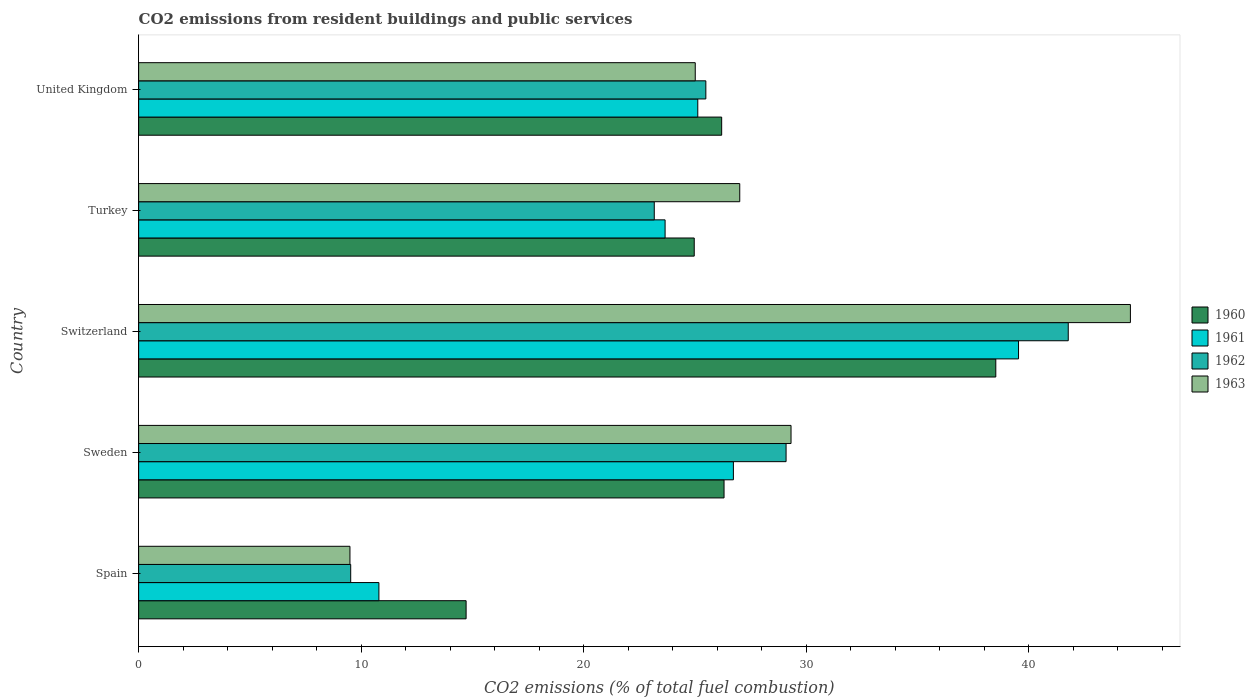How many different coloured bars are there?
Make the answer very short. 4. How many groups of bars are there?
Make the answer very short. 5. Are the number of bars on each tick of the Y-axis equal?
Make the answer very short. Yes. How many bars are there on the 1st tick from the top?
Make the answer very short. 4. What is the label of the 5th group of bars from the top?
Offer a very short reply. Spain. What is the total CO2 emitted in 1960 in Switzerland?
Offer a very short reply. 38.52. Across all countries, what is the maximum total CO2 emitted in 1961?
Your answer should be compact. 39.54. Across all countries, what is the minimum total CO2 emitted in 1960?
Offer a very short reply. 14.72. In which country was the total CO2 emitted in 1960 maximum?
Your response must be concise. Switzerland. What is the total total CO2 emitted in 1963 in the graph?
Offer a very short reply. 135.42. What is the difference between the total CO2 emitted in 1961 in Sweden and that in Turkey?
Ensure brevity in your answer.  3.07. What is the difference between the total CO2 emitted in 1960 in Switzerland and the total CO2 emitted in 1962 in United Kingdom?
Offer a terse response. 13.03. What is the average total CO2 emitted in 1961 per country?
Your answer should be very brief. 25.17. What is the difference between the total CO2 emitted in 1961 and total CO2 emitted in 1960 in Turkey?
Give a very brief answer. -1.31. What is the ratio of the total CO2 emitted in 1961 in Spain to that in United Kingdom?
Give a very brief answer. 0.43. What is the difference between the highest and the second highest total CO2 emitted in 1961?
Keep it short and to the point. 12.81. What is the difference between the highest and the lowest total CO2 emitted in 1963?
Ensure brevity in your answer.  35.07. In how many countries, is the total CO2 emitted in 1960 greater than the average total CO2 emitted in 1960 taken over all countries?
Provide a short and direct response. 3. What does the 3rd bar from the bottom in Sweden represents?
Offer a terse response. 1962. Is it the case that in every country, the sum of the total CO2 emitted in 1963 and total CO2 emitted in 1962 is greater than the total CO2 emitted in 1960?
Your answer should be compact. Yes. How many bars are there?
Ensure brevity in your answer.  20. Does the graph contain any zero values?
Offer a terse response. No. How many legend labels are there?
Offer a very short reply. 4. How are the legend labels stacked?
Your answer should be very brief. Vertical. What is the title of the graph?
Keep it short and to the point. CO2 emissions from resident buildings and public services. Does "1995" appear as one of the legend labels in the graph?
Make the answer very short. No. What is the label or title of the X-axis?
Provide a succinct answer. CO2 emissions (% of total fuel combustion). What is the CO2 emissions (% of total fuel combustion) in 1960 in Spain?
Your answer should be very brief. 14.72. What is the CO2 emissions (% of total fuel combustion) in 1961 in Spain?
Make the answer very short. 10.8. What is the CO2 emissions (% of total fuel combustion) in 1962 in Spain?
Your answer should be compact. 9.53. What is the CO2 emissions (% of total fuel combustion) of 1963 in Spain?
Your answer should be very brief. 9.5. What is the CO2 emissions (% of total fuel combustion) in 1960 in Sweden?
Provide a short and direct response. 26.31. What is the CO2 emissions (% of total fuel combustion) of 1961 in Sweden?
Give a very brief answer. 26.73. What is the CO2 emissions (% of total fuel combustion) of 1962 in Sweden?
Ensure brevity in your answer.  29.1. What is the CO2 emissions (% of total fuel combustion) in 1963 in Sweden?
Your answer should be very brief. 29.32. What is the CO2 emissions (% of total fuel combustion) in 1960 in Switzerland?
Offer a very short reply. 38.52. What is the CO2 emissions (% of total fuel combustion) of 1961 in Switzerland?
Offer a very short reply. 39.54. What is the CO2 emissions (% of total fuel combustion) in 1962 in Switzerland?
Provide a succinct answer. 41.78. What is the CO2 emissions (% of total fuel combustion) of 1963 in Switzerland?
Keep it short and to the point. 44.57. What is the CO2 emissions (% of total fuel combustion) of 1960 in Turkey?
Your answer should be compact. 24.97. What is the CO2 emissions (% of total fuel combustion) in 1961 in Turkey?
Ensure brevity in your answer.  23.66. What is the CO2 emissions (% of total fuel combustion) of 1962 in Turkey?
Offer a very short reply. 23.17. What is the CO2 emissions (% of total fuel combustion) in 1963 in Turkey?
Offer a terse response. 27.01. What is the CO2 emissions (% of total fuel combustion) of 1960 in United Kingdom?
Provide a short and direct response. 26.2. What is the CO2 emissions (% of total fuel combustion) of 1961 in United Kingdom?
Provide a succinct answer. 25.13. What is the CO2 emissions (% of total fuel combustion) in 1962 in United Kingdom?
Your answer should be very brief. 25.49. What is the CO2 emissions (% of total fuel combustion) of 1963 in United Kingdom?
Provide a short and direct response. 25.01. Across all countries, what is the maximum CO2 emissions (% of total fuel combustion) in 1960?
Your answer should be very brief. 38.52. Across all countries, what is the maximum CO2 emissions (% of total fuel combustion) in 1961?
Keep it short and to the point. 39.54. Across all countries, what is the maximum CO2 emissions (% of total fuel combustion) in 1962?
Give a very brief answer. 41.78. Across all countries, what is the maximum CO2 emissions (% of total fuel combustion) of 1963?
Ensure brevity in your answer.  44.57. Across all countries, what is the minimum CO2 emissions (% of total fuel combustion) of 1960?
Give a very brief answer. 14.72. Across all countries, what is the minimum CO2 emissions (% of total fuel combustion) of 1961?
Offer a terse response. 10.8. Across all countries, what is the minimum CO2 emissions (% of total fuel combustion) of 1962?
Offer a terse response. 9.53. Across all countries, what is the minimum CO2 emissions (% of total fuel combustion) in 1963?
Ensure brevity in your answer.  9.5. What is the total CO2 emissions (% of total fuel combustion) of 1960 in the graph?
Provide a short and direct response. 130.72. What is the total CO2 emissions (% of total fuel combustion) of 1961 in the graph?
Give a very brief answer. 125.86. What is the total CO2 emissions (% of total fuel combustion) in 1962 in the graph?
Your answer should be very brief. 129.07. What is the total CO2 emissions (% of total fuel combustion) in 1963 in the graph?
Offer a terse response. 135.42. What is the difference between the CO2 emissions (% of total fuel combustion) in 1960 in Spain and that in Sweden?
Give a very brief answer. -11.59. What is the difference between the CO2 emissions (% of total fuel combustion) in 1961 in Spain and that in Sweden?
Offer a terse response. -15.93. What is the difference between the CO2 emissions (% of total fuel combustion) in 1962 in Spain and that in Sweden?
Offer a very short reply. -19.57. What is the difference between the CO2 emissions (% of total fuel combustion) of 1963 in Spain and that in Sweden?
Your response must be concise. -19.82. What is the difference between the CO2 emissions (% of total fuel combustion) of 1960 in Spain and that in Switzerland?
Your answer should be compact. -23.8. What is the difference between the CO2 emissions (% of total fuel combustion) of 1961 in Spain and that in Switzerland?
Your response must be concise. -28.75. What is the difference between the CO2 emissions (% of total fuel combustion) in 1962 in Spain and that in Switzerland?
Your answer should be compact. -32.25. What is the difference between the CO2 emissions (% of total fuel combustion) of 1963 in Spain and that in Switzerland?
Offer a terse response. -35.07. What is the difference between the CO2 emissions (% of total fuel combustion) in 1960 in Spain and that in Turkey?
Ensure brevity in your answer.  -10.25. What is the difference between the CO2 emissions (% of total fuel combustion) in 1961 in Spain and that in Turkey?
Offer a very short reply. -12.86. What is the difference between the CO2 emissions (% of total fuel combustion) in 1962 in Spain and that in Turkey?
Offer a terse response. -13.64. What is the difference between the CO2 emissions (% of total fuel combustion) in 1963 in Spain and that in Turkey?
Your answer should be compact. -17.52. What is the difference between the CO2 emissions (% of total fuel combustion) in 1960 in Spain and that in United Kingdom?
Keep it short and to the point. -11.49. What is the difference between the CO2 emissions (% of total fuel combustion) of 1961 in Spain and that in United Kingdom?
Your answer should be very brief. -14.33. What is the difference between the CO2 emissions (% of total fuel combustion) of 1962 in Spain and that in United Kingdom?
Offer a very short reply. -15.96. What is the difference between the CO2 emissions (% of total fuel combustion) in 1963 in Spain and that in United Kingdom?
Your answer should be compact. -15.52. What is the difference between the CO2 emissions (% of total fuel combustion) of 1960 in Sweden and that in Switzerland?
Keep it short and to the point. -12.21. What is the difference between the CO2 emissions (% of total fuel combustion) in 1961 in Sweden and that in Switzerland?
Your answer should be compact. -12.81. What is the difference between the CO2 emissions (% of total fuel combustion) in 1962 in Sweden and that in Switzerland?
Make the answer very short. -12.68. What is the difference between the CO2 emissions (% of total fuel combustion) in 1963 in Sweden and that in Switzerland?
Offer a terse response. -15.25. What is the difference between the CO2 emissions (% of total fuel combustion) in 1960 in Sweden and that in Turkey?
Provide a short and direct response. 1.34. What is the difference between the CO2 emissions (% of total fuel combustion) in 1961 in Sweden and that in Turkey?
Your answer should be very brief. 3.07. What is the difference between the CO2 emissions (% of total fuel combustion) of 1962 in Sweden and that in Turkey?
Provide a short and direct response. 5.92. What is the difference between the CO2 emissions (% of total fuel combustion) in 1963 in Sweden and that in Turkey?
Make the answer very short. 2.3. What is the difference between the CO2 emissions (% of total fuel combustion) of 1960 in Sweden and that in United Kingdom?
Keep it short and to the point. 0.11. What is the difference between the CO2 emissions (% of total fuel combustion) in 1961 in Sweden and that in United Kingdom?
Offer a terse response. 1.6. What is the difference between the CO2 emissions (% of total fuel combustion) of 1962 in Sweden and that in United Kingdom?
Keep it short and to the point. 3.61. What is the difference between the CO2 emissions (% of total fuel combustion) in 1963 in Sweden and that in United Kingdom?
Give a very brief answer. 4.3. What is the difference between the CO2 emissions (% of total fuel combustion) in 1960 in Switzerland and that in Turkey?
Ensure brevity in your answer.  13.55. What is the difference between the CO2 emissions (% of total fuel combustion) of 1961 in Switzerland and that in Turkey?
Give a very brief answer. 15.88. What is the difference between the CO2 emissions (% of total fuel combustion) in 1962 in Switzerland and that in Turkey?
Provide a succinct answer. 18.6. What is the difference between the CO2 emissions (% of total fuel combustion) in 1963 in Switzerland and that in Turkey?
Keep it short and to the point. 17.56. What is the difference between the CO2 emissions (% of total fuel combustion) in 1960 in Switzerland and that in United Kingdom?
Offer a very short reply. 12.32. What is the difference between the CO2 emissions (% of total fuel combustion) in 1961 in Switzerland and that in United Kingdom?
Give a very brief answer. 14.42. What is the difference between the CO2 emissions (% of total fuel combustion) of 1962 in Switzerland and that in United Kingdom?
Your answer should be very brief. 16.29. What is the difference between the CO2 emissions (% of total fuel combustion) of 1963 in Switzerland and that in United Kingdom?
Offer a very short reply. 19.56. What is the difference between the CO2 emissions (% of total fuel combustion) of 1960 in Turkey and that in United Kingdom?
Provide a short and direct response. -1.23. What is the difference between the CO2 emissions (% of total fuel combustion) of 1961 in Turkey and that in United Kingdom?
Make the answer very short. -1.47. What is the difference between the CO2 emissions (% of total fuel combustion) of 1962 in Turkey and that in United Kingdom?
Your answer should be compact. -2.32. What is the difference between the CO2 emissions (% of total fuel combustion) of 1963 in Turkey and that in United Kingdom?
Your answer should be very brief. 2. What is the difference between the CO2 emissions (% of total fuel combustion) of 1960 in Spain and the CO2 emissions (% of total fuel combustion) of 1961 in Sweden?
Your answer should be compact. -12.01. What is the difference between the CO2 emissions (% of total fuel combustion) in 1960 in Spain and the CO2 emissions (% of total fuel combustion) in 1962 in Sweden?
Provide a short and direct response. -14.38. What is the difference between the CO2 emissions (% of total fuel combustion) of 1960 in Spain and the CO2 emissions (% of total fuel combustion) of 1963 in Sweden?
Give a very brief answer. -14.6. What is the difference between the CO2 emissions (% of total fuel combustion) of 1961 in Spain and the CO2 emissions (% of total fuel combustion) of 1962 in Sweden?
Your answer should be very brief. -18.3. What is the difference between the CO2 emissions (% of total fuel combustion) of 1961 in Spain and the CO2 emissions (% of total fuel combustion) of 1963 in Sweden?
Your answer should be very brief. -18.52. What is the difference between the CO2 emissions (% of total fuel combustion) of 1962 in Spain and the CO2 emissions (% of total fuel combustion) of 1963 in Sweden?
Keep it short and to the point. -19.79. What is the difference between the CO2 emissions (% of total fuel combustion) in 1960 in Spain and the CO2 emissions (% of total fuel combustion) in 1961 in Switzerland?
Offer a very short reply. -24.83. What is the difference between the CO2 emissions (% of total fuel combustion) of 1960 in Spain and the CO2 emissions (% of total fuel combustion) of 1962 in Switzerland?
Make the answer very short. -27.06. What is the difference between the CO2 emissions (% of total fuel combustion) of 1960 in Spain and the CO2 emissions (% of total fuel combustion) of 1963 in Switzerland?
Keep it short and to the point. -29.85. What is the difference between the CO2 emissions (% of total fuel combustion) in 1961 in Spain and the CO2 emissions (% of total fuel combustion) in 1962 in Switzerland?
Your answer should be very brief. -30.98. What is the difference between the CO2 emissions (% of total fuel combustion) of 1961 in Spain and the CO2 emissions (% of total fuel combustion) of 1963 in Switzerland?
Your response must be concise. -33.77. What is the difference between the CO2 emissions (% of total fuel combustion) in 1962 in Spain and the CO2 emissions (% of total fuel combustion) in 1963 in Switzerland?
Give a very brief answer. -35.04. What is the difference between the CO2 emissions (% of total fuel combustion) of 1960 in Spain and the CO2 emissions (% of total fuel combustion) of 1961 in Turkey?
Ensure brevity in your answer.  -8.94. What is the difference between the CO2 emissions (% of total fuel combustion) in 1960 in Spain and the CO2 emissions (% of total fuel combustion) in 1962 in Turkey?
Your response must be concise. -8.46. What is the difference between the CO2 emissions (% of total fuel combustion) of 1960 in Spain and the CO2 emissions (% of total fuel combustion) of 1963 in Turkey?
Keep it short and to the point. -12.3. What is the difference between the CO2 emissions (% of total fuel combustion) in 1961 in Spain and the CO2 emissions (% of total fuel combustion) in 1962 in Turkey?
Offer a very short reply. -12.38. What is the difference between the CO2 emissions (% of total fuel combustion) of 1961 in Spain and the CO2 emissions (% of total fuel combustion) of 1963 in Turkey?
Give a very brief answer. -16.22. What is the difference between the CO2 emissions (% of total fuel combustion) in 1962 in Spain and the CO2 emissions (% of total fuel combustion) in 1963 in Turkey?
Offer a terse response. -17.48. What is the difference between the CO2 emissions (% of total fuel combustion) of 1960 in Spain and the CO2 emissions (% of total fuel combustion) of 1961 in United Kingdom?
Your answer should be very brief. -10.41. What is the difference between the CO2 emissions (% of total fuel combustion) of 1960 in Spain and the CO2 emissions (% of total fuel combustion) of 1962 in United Kingdom?
Provide a short and direct response. -10.77. What is the difference between the CO2 emissions (% of total fuel combustion) in 1960 in Spain and the CO2 emissions (% of total fuel combustion) in 1963 in United Kingdom?
Offer a terse response. -10.3. What is the difference between the CO2 emissions (% of total fuel combustion) of 1961 in Spain and the CO2 emissions (% of total fuel combustion) of 1962 in United Kingdom?
Offer a terse response. -14.69. What is the difference between the CO2 emissions (% of total fuel combustion) of 1961 in Spain and the CO2 emissions (% of total fuel combustion) of 1963 in United Kingdom?
Give a very brief answer. -14.22. What is the difference between the CO2 emissions (% of total fuel combustion) of 1962 in Spain and the CO2 emissions (% of total fuel combustion) of 1963 in United Kingdom?
Provide a succinct answer. -15.48. What is the difference between the CO2 emissions (% of total fuel combustion) in 1960 in Sweden and the CO2 emissions (% of total fuel combustion) in 1961 in Switzerland?
Ensure brevity in your answer.  -13.23. What is the difference between the CO2 emissions (% of total fuel combustion) of 1960 in Sweden and the CO2 emissions (% of total fuel combustion) of 1962 in Switzerland?
Make the answer very short. -15.47. What is the difference between the CO2 emissions (% of total fuel combustion) of 1960 in Sweden and the CO2 emissions (% of total fuel combustion) of 1963 in Switzerland?
Give a very brief answer. -18.26. What is the difference between the CO2 emissions (% of total fuel combustion) of 1961 in Sweden and the CO2 emissions (% of total fuel combustion) of 1962 in Switzerland?
Your answer should be very brief. -15.05. What is the difference between the CO2 emissions (% of total fuel combustion) of 1961 in Sweden and the CO2 emissions (% of total fuel combustion) of 1963 in Switzerland?
Offer a terse response. -17.84. What is the difference between the CO2 emissions (% of total fuel combustion) in 1962 in Sweden and the CO2 emissions (% of total fuel combustion) in 1963 in Switzerland?
Provide a succinct answer. -15.47. What is the difference between the CO2 emissions (% of total fuel combustion) of 1960 in Sweden and the CO2 emissions (% of total fuel combustion) of 1961 in Turkey?
Your answer should be compact. 2.65. What is the difference between the CO2 emissions (% of total fuel combustion) in 1960 in Sweden and the CO2 emissions (% of total fuel combustion) in 1962 in Turkey?
Give a very brief answer. 3.14. What is the difference between the CO2 emissions (% of total fuel combustion) of 1960 in Sweden and the CO2 emissions (% of total fuel combustion) of 1963 in Turkey?
Your answer should be very brief. -0.71. What is the difference between the CO2 emissions (% of total fuel combustion) of 1961 in Sweden and the CO2 emissions (% of total fuel combustion) of 1962 in Turkey?
Ensure brevity in your answer.  3.56. What is the difference between the CO2 emissions (% of total fuel combustion) in 1961 in Sweden and the CO2 emissions (% of total fuel combustion) in 1963 in Turkey?
Keep it short and to the point. -0.29. What is the difference between the CO2 emissions (% of total fuel combustion) in 1962 in Sweden and the CO2 emissions (% of total fuel combustion) in 1963 in Turkey?
Keep it short and to the point. 2.08. What is the difference between the CO2 emissions (% of total fuel combustion) of 1960 in Sweden and the CO2 emissions (% of total fuel combustion) of 1961 in United Kingdom?
Offer a terse response. 1.18. What is the difference between the CO2 emissions (% of total fuel combustion) of 1960 in Sweden and the CO2 emissions (% of total fuel combustion) of 1962 in United Kingdom?
Provide a succinct answer. 0.82. What is the difference between the CO2 emissions (% of total fuel combustion) of 1960 in Sweden and the CO2 emissions (% of total fuel combustion) of 1963 in United Kingdom?
Ensure brevity in your answer.  1.29. What is the difference between the CO2 emissions (% of total fuel combustion) of 1961 in Sweden and the CO2 emissions (% of total fuel combustion) of 1962 in United Kingdom?
Your response must be concise. 1.24. What is the difference between the CO2 emissions (% of total fuel combustion) in 1961 in Sweden and the CO2 emissions (% of total fuel combustion) in 1963 in United Kingdom?
Provide a short and direct response. 1.71. What is the difference between the CO2 emissions (% of total fuel combustion) of 1962 in Sweden and the CO2 emissions (% of total fuel combustion) of 1963 in United Kingdom?
Offer a very short reply. 4.08. What is the difference between the CO2 emissions (% of total fuel combustion) in 1960 in Switzerland and the CO2 emissions (% of total fuel combustion) in 1961 in Turkey?
Provide a succinct answer. 14.86. What is the difference between the CO2 emissions (% of total fuel combustion) in 1960 in Switzerland and the CO2 emissions (% of total fuel combustion) in 1962 in Turkey?
Provide a succinct answer. 15.35. What is the difference between the CO2 emissions (% of total fuel combustion) of 1960 in Switzerland and the CO2 emissions (% of total fuel combustion) of 1963 in Turkey?
Make the answer very short. 11.51. What is the difference between the CO2 emissions (% of total fuel combustion) of 1961 in Switzerland and the CO2 emissions (% of total fuel combustion) of 1962 in Turkey?
Give a very brief answer. 16.37. What is the difference between the CO2 emissions (% of total fuel combustion) in 1961 in Switzerland and the CO2 emissions (% of total fuel combustion) in 1963 in Turkey?
Give a very brief answer. 12.53. What is the difference between the CO2 emissions (% of total fuel combustion) of 1962 in Switzerland and the CO2 emissions (% of total fuel combustion) of 1963 in Turkey?
Keep it short and to the point. 14.76. What is the difference between the CO2 emissions (% of total fuel combustion) in 1960 in Switzerland and the CO2 emissions (% of total fuel combustion) in 1961 in United Kingdom?
Your response must be concise. 13.39. What is the difference between the CO2 emissions (% of total fuel combustion) of 1960 in Switzerland and the CO2 emissions (% of total fuel combustion) of 1962 in United Kingdom?
Your answer should be very brief. 13.03. What is the difference between the CO2 emissions (% of total fuel combustion) of 1960 in Switzerland and the CO2 emissions (% of total fuel combustion) of 1963 in United Kingdom?
Provide a short and direct response. 13.51. What is the difference between the CO2 emissions (% of total fuel combustion) in 1961 in Switzerland and the CO2 emissions (% of total fuel combustion) in 1962 in United Kingdom?
Your answer should be very brief. 14.05. What is the difference between the CO2 emissions (% of total fuel combustion) in 1961 in Switzerland and the CO2 emissions (% of total fuel combustion) in 1963 in United Kingdom?
Your response must be concise. 14.53. What is the difference between the CO2 emissions (% of total fuel combustion) in 1962 in Switzerland and the CO2 emissions (% of total fuel combustion) in 1963 in United Kingdom?
Your answer should be very brief. 16.76. What is the difference between the CO2 emissions (% of total fuel combustion) of 1960 in Turkey and the CO2 emissions (% of total fuel combustion) of 1961 in United Kingdom?
Offer a very short reply. -0.16. What is the difference between the CO2 emissions (% of total fuel combustion) of 1960 in Turkey and the CO2 emissions (% of total fuel combustion) of 1962 in United Kingdom?
Make the answer very short. -0.52. What is the difference between the CO2 emissions (% of total fuel combustion) in 1960 in Turkey and the CO2 emissions (% of total fuel combustion) in 1963 in United Kingdom?
Make the answer very short. -0.05. What is the difference between the CO2 emissions (% of total fuel combustion) in 1961 in Turkey and the CO2 emissions (% of total fuel combustion) in 1962 in United Kingdom?
Offer a very short reply. -1.83. What is the difference between the CO2 emissions (% of total fuel combustion) in 1961 in Turkey and the CO2 emissions (% of total fuel combustion) in 1963 in United Kingdom?
Provide a succinct answer. -1.35. What is the difference between the CO2 emissions (% of total fuel combustion) in 1962 in Turkey and the CO2 emissions (% of total fuel combustion) in 1963 in United Kingdom?
Give a very brief answer. -1.84. What is the average CO2 emissions (% of total fuel combustion) in 1960 per country?
Make the answer very short. 26.14. What is the average CO2 emissions (% of total fuel combustion) of 1961 per country?
Your response must be concise. 25.17. What is the average CO2 emissions (% of total fuel combustion) in 1962 per country?
Provide a succinct answer. 25.81. What is the average CO2 emissions (% of total fuel combustion) of 1963 per country?
Offer a very short reply. 27.08. What is the difference between the CO2 emissions (% of total fuel combustion) in 1960 and CO2 emissions (% of total fuel combustion) in 1961 in Spain?
Make the answer very short. 3.92. What is the difference between the CO2 emissions (% of total fuel combustion) in 1960 and CO2 emissions (% of total fuel combustion) in 1962 in Spain?
Ensure brevity in your answer.  5.19. What is the difference between the CO2 emissions (% of total fuel combustion) of 1960 and CO2 emissions (% of total fuel combustion) of 1963 in Spain?
Make the answer very short. 5.22. What is the difference between the CO2 emissions (% of total fuel combustion) of 1961 and CO2 emissions (% of total fuel combustion) of 1962 in Spain?
Your answer should be very brief. 1.27. What is the difference between the CO2 emissions (% of total fuel combustion) of 1961 and CO2 emissions (% of total fuel combustion) of 1963 in Spain?
Ensure brevity in your answer.  1.3. What is the difference between the CO2 emissions (% of total fuel combustion) in 1962 and CO2 emissions (% of total fuel combustion) in 1963 in Spain?
Your answer should be compact. 0.03. What is the difference between the CO2 emissions (% of total fuel combustion) in 1960 and CO2 emissions (% of total fuel combustion) in 1961 in Sweden?
Your answer should be very brief. -0.42. What is the difference between the CO2 emissions (% of total fuel combustion) in 1960 and CO2 emissions (% of total fuel combustion) in 1962 in Sweden?
Your response must be concise. -2.79. What is the difference between the CO2 emissions (% of total fuel combustion) of 1960 and CO2 emissions (% of total fuel combustion) of 1963 in Sweden?
Your response must be concise. -3.01. What is the difference between the CO2 emissions (% of total fuel combustion) in 1961 and CO2 emissions (% of total fuel combustion) in 1962 in Sweden?
Provide a succinct answer. -2.37. What is the difference between the CO2 emissions (% of total fuel combustion) of 1961 and CO2 emissions (% of total fuel combustion) of 1963 in Sweden?
Give a very brief answer. -2.59. What is the difference between the CO2 emissions (% of total fuel combustion) of 1962 and CO2 emissions (% of total fuel combustion) of 1963 in Sweden?
Your response must be concise. -0.22. What is the difference between the CO2 emissions (% of total fuel combustion) of 1960 and CO2 emissions (% of total fuel combustion) of 1961 in Switzerland?
Make the answer very short. -1.02. What is the difference between the CO2 emissions (% of total fuel combustion) in 1960 and CO2 emissions (% of total fuel combustion) in 1962 in Switzerland?
Keep it short and to the point. -3.26. What is the difference between the CO2 emissions (% of total fuel combustion) in 1960 and CO2 emissions (% of total fuel combustion) in 1963 in Switzerland?
Ensure brevity in your answer.  -6.05. What is the difference between the CO2 emissions (% of total fuel combustion) in 1961 and CO2 emissions (% of total fuel combustion) in 1962 in Switzerland?
Provide a short and direct response. -2.23. What is the difference between the CO2 emissions (% of total fuel combustion) in 1961 and CO2 emissions (% of total fuel combustion) in 1963 in Switzerland?
Your response must be concise. -5.03. What is the difference between the CO2 emissions (% of total fuel combustion) of 1962 and CO2 emissions (% of total fuel combustion) of 1963 in Switzerland?
Offer a very short reply. -2.79. What is the difference between the CO2 emissions (% of total fuel combustion) of 1960 and CO2 emissions (% of total fuel combustion) of 1961 in Turkey?
Provide a succinct answer. 1.31. What is the difference between the CO2 emissions (% of total fuel combustion) in 1960 and CO2 emissions (% of total fuel combustion) in 1962 in Turkey?
Offer a terse response. 1.8. What is the difference between the CO2 emissions (% of total fuel combustion) in 1960 and CO2 emissions (% of total fuel combustion) in 1963 in Turkey?
Provide a succinct answer. -2.05. What is the difference between the CO2 emissions (% of total fuel combustion) in 1961 and CO2 emissions (% of total fuel combustion) in 1962 in Turkey?
Offer a very short reply. 0.49. What is the difference between the CO2 emissions (% of total fuel combustion) in 1961 and CO2 emissions (% of total fuel combustion) in 1963 in Turkey?
Your response must be concise. -3.35. What is the difference between the CO2 emissions (% of total fuel combustion) in 1962 and CO2 emissions (% of total fuel combustion) in 1963 in Turkey?
Your response must be concise. -3.84. What is the difference between the CO2 emissions (% of total fuel combustion) in 1960 and CO2 emissions (% of total fuel combustion) in 1961 in United Kingdom?
Make the answer very short. 1.07. What is the difference between the CO2 emissions (% of total fuel combustion) in 1960 and CO2 emissions (% of total fuel combustion) in 1962 in United Kingdom?
Make the answer very short. 0.71. What is the difference between the CO2 emissions (% of total fuel combustion) in 1960 and CO2 emissions (% of total fuel combustion) in 1963 in United Kingdom?
Make the answer very short. 1.19. What is the difference between the CO2 emissions (% of total fuel combustion) in 1961 and CO2 emissions (% of total fuel combustion) in 1962 in United Kingdom?
Make the answer very short. -0.36. What is the difference between the CO2 emissions (% of total fuel combustion) of 1961 and CO2 emissions (% of total fuel combustion) of 1963 in United Kingdom?
Give a very brief answer. 0.11. What is the difference between the CO2 emissions (% of total fuel combustion) of 1962 and CO2 emissions (% of total fuel combustion) of 1963 in United Kingdom?
Provide a succinct answer. 0.48. What is the ratio of the CO2 emissions (% of total fuel combustion) of 1960 in Spain to that in Sweden?
Your response must be concise. 0.56. What is the ratio of the CO2 emissions (% of total fuel combustion) in 1961 in Spain to that in Sweden?
Offer a terse response. 0.4. What is the ratio of the CO2 emissions (% of total fuel combustion) in 1962 in Spain to that in Sweden?
Provide a succinct answer. 0.33. What is the ratio of the CO2 emissions (% of total fuel combustion) in 1963 in Spain to that in Sweden?
Keep it short and to the point. 0.32. What is the ratio of the CO2 emissions (% of total fuel combustion) of 1960 in Spain to that in Switzerland?
Offer a terse response. 0.38. What is the ratio of the CO2 emissions (% of total fuel combustion) in 1961 in Spain to that in Switzerland?
Provide a succinct answer. 0.27. What is the ratio of the CO2 emissions (% of total fuel combustion) in 1962 in Spain to that in Switzerland?
Provide a short and direct response. 0.23. What is the ratio of the CO2 emissions (% of total fuel combustion) of 1963 in Spain to that in Switzerland?
Make the answer very short. 0.21. What is the ratio of the CO2 emissions (% of total fuel combustion) in 1960 in Spain to that in Turkey?
Offer a terse response. 0.59. What is the ratio of the CO2 emissions (% of total fuel combustion) of 1961 in Spain to that in Turkey?
Give a very brief answer. 0.46. What is the ratio of the CO2 emissions (% of total fuel combustion) in 1962 in Spain to that in Turkey?
Your answer should be compact. 0.41. What is the ratio of the CO2 emissions (% of total fuel combustion) of 1963 in Spain to that in Turkey?
Provide a short and direct response. 0.35. What is the ratio of the CO2 emissions (% of total fuel combustion) in 1960 in Spain to that in United Kingdom?
Provide a succinct answer. 0.56. What is the ratio of the CO2 emissions (% of total fuel combustion) of 1961 in Spain to that in United Kingdom?
Your answer should be compact. 0.43. What is the ratio of the CO2 emissions (% of total fuel combustion) in 1962 in Spain to that in United Kingdom?
Offer a terse response. 0.37. What is the ratio of the CO2 emissions (% of total fuel combustion) of 1963 in Spain to that in United Kingdom?
Your response must be concise. 0.38. What is the ratio of the CO2 emissions (% of total fuel combustion) of 1960 in Sweden to that in Switzerland?
Your answer should be compact. 0.68. What is the ratio of the CO2 emissions (% of total fuel combustion) of 1961 in Sweden to that in Switzerland?
Your answer should be compact. 0.68. What is the ratio of the CO2 emissions (% of total fuel combustion) of 1962 in Sweden to that in Switzerland?
Keep it short and to the point. 0.7. What is the ratio of the CO2 emissions (% of total fuel combustion) of 1963 in Sweden to that in Switzerland?
Your answer should be compact. 0.66. What is the ratio of the CO2 emissions (% of total fuel combustion) in 1960 in Sweden to that in Turkey?
Keep it short and to the point. 1.05. What is the ratio of the CO2 emissions (% of total fuel combustion) in 1961 in Sweden to that in Turkey?
Provide a succinct answer. 1.13. What is the ratio of the CO2 emissions (% of total fuel combustion) of 1962 in Sweden to that in Turkey?
Provide a succinct answer. 1.26. What is the ratio of the CO2 emissions (% of total fuel combustion) of 1963 in Sweden to that in Turkey?
Your answer should be very brief. 1.09. What is the ratio of the CO2 emissions (% of total fuel combustion) in 1960 in Sweden to that in United Kingdom?
Ensure brevity in your answer.  1. What is the ratio of the CO2 emissions (% of total fuel combustion) of 1961 in Sweden to that in United Kingdom?
Offer a terse response. 1.06. What is the ratio of the CO2 emissions (% of total fuel combustion) of 1962 in Sweden to that in United Kingdom?
Keep it short and to the point. 1.14. What is the ratio of the CO2 emissions (% of total fuel combustion) in 1963 in Sweden to that in United Kingdom?
Keep it short and to the point. 1.17. What is the ratio of the CO2 emissions (% of total fuel combustion) of 1960 in Switzerland to that in Turkey?
Your response must be concise. 1.54. What is the ratio of the CO2 emissions (% of total fuel combustion) of 1961 in Switzerland to that in Turkey?
Give a very brief answer. 1.67. What is the ratio of the CO2 emissions (% of total fuel combustion) of 1962 in Switzerland to that in Turkey?
Offer a very short reply. 1.8. What is the ratio of the CO2 emissions (% of total fuel combustion) in 1963 in Switzerland to that in Turkey?
Your answer should be compact. 1.65. What is the ratio of the CO2 emissions (% of total fuel combustion) in 1960 in Switzerland to that in United Kingdom?
Your response must be concise. 1.47. What is the ratio of the CO2 emissions (% of total fuel combustion) in 1961 in Switzerland to that in United Kingdom?
Give a very brief answer. 1.57. What is the ratio of the CO2 emissions (% of total fuel combustion) in 1962 in Switzerland to that in United Kingdom?
Your answer should be compact. 1.64. What is the ratio of the CO2 emissions (% of total fuel combustion) of 1963 in Switzerland to that in United Kingdom?
Keep it short and to the point. 1.78. What is the ratio of the CO2 emissions (% of total fuel combustion) in 1960 in Turkey to that in United Kingdom?
Provide a succinct answer. 0.95. What is the ratio of the CO2 emissions (% of total fuel combustion) of 1961 in Turkey to that in United Kingdom?
Make the answer very short. 0.94. What is the difference between the highest and the second highest CO2 emissions (% of total fuel combustion) in 1960?
Offer a very short reply. 12.21. What is the difference between the highest and the second highest CO2 emissions (% of total fuel combustion) in 1961?
Your answer should be very brief. 12.81. What is the difference between the highest and the second highest CO2 emissions (% of total fuel combustion) of 1962?
Provide a succinct answer. 12.68. What is the difference between the highest and the second highest CO2 emissions (% of total fuel combustion) of 1963?
Offer a terse response. 15.25. What is the difference between the highest and the lowest CO2 emissions (% of total fuel combustion) in 1960?
Make the answer very short. 23.8. What is the difference between the highest and the lowest CO2 emissions (% of total fuel combustion) in 1961?
Your response must be concise. 28.75. What is the difference between the highest and the lowest CO2 emissions (% of total fuel combustion) of 1962?
Give a very brief answer. 32.25. What is the difference between the highest and the lowest CO2 emissions (% of total fuel combustion) of 1963?
Ensure brevity in your answer.  35.07. 